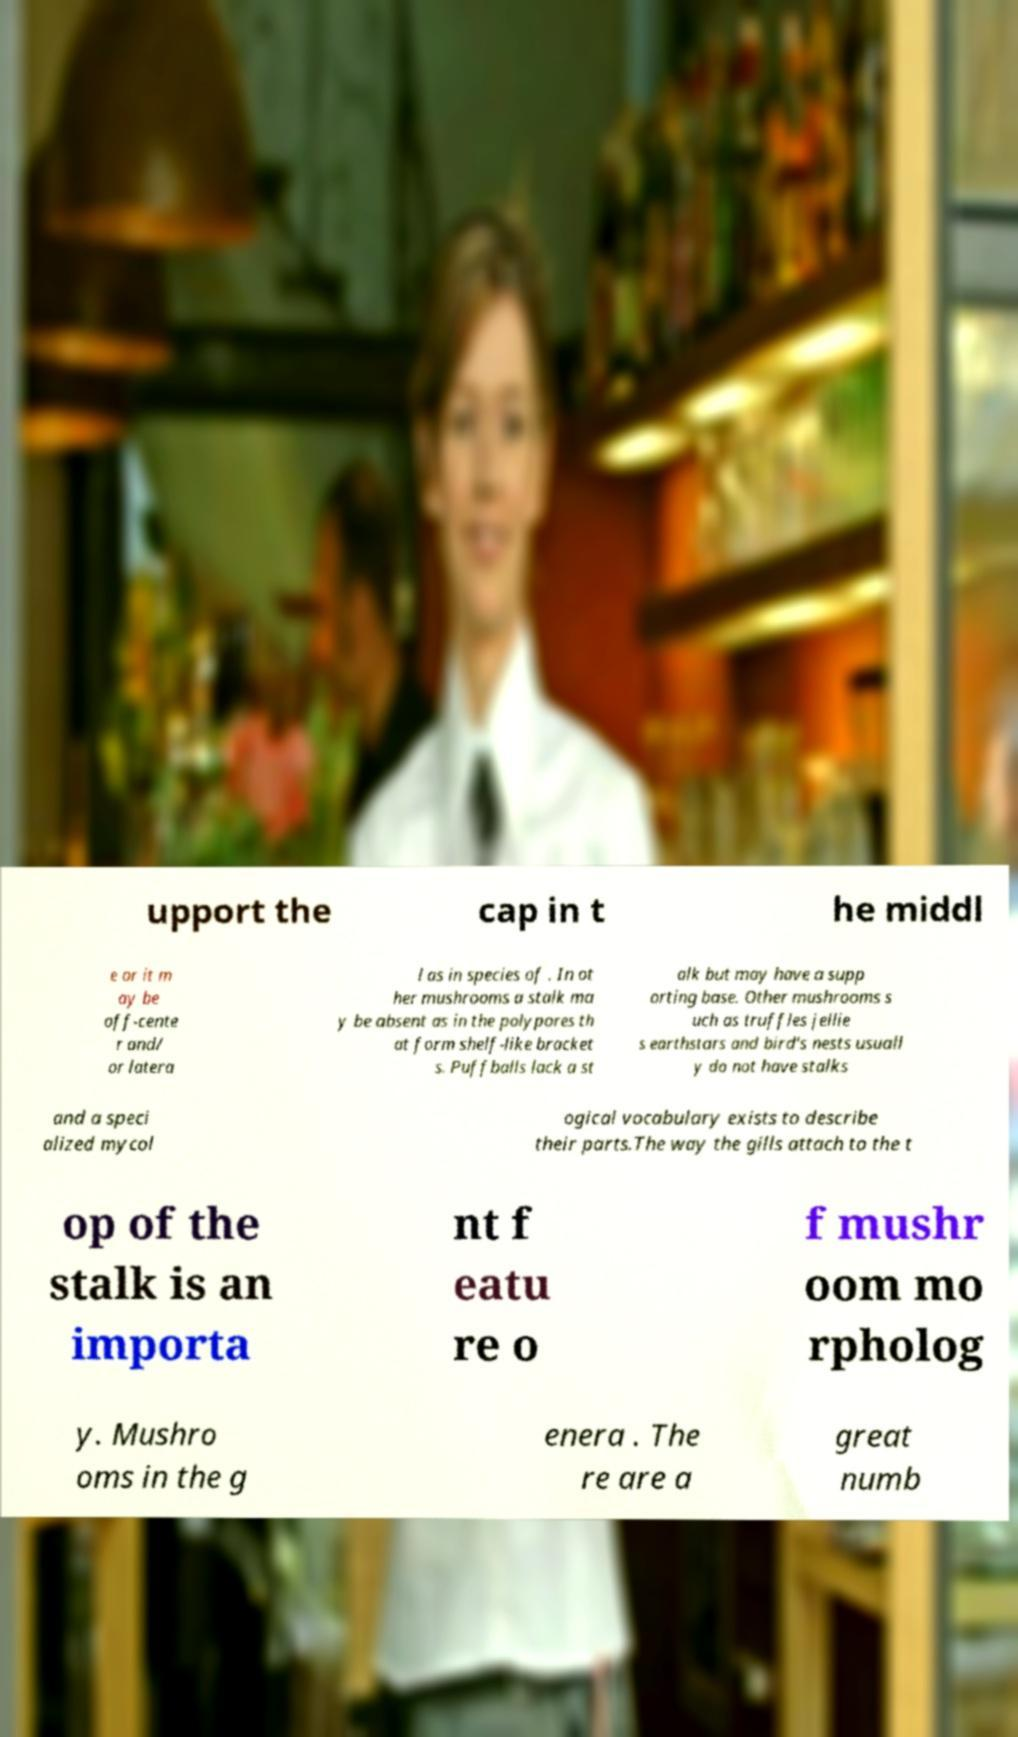Could you assist in decoding the text presented in this image and type it out clearly? upport the cap in t he middl e or it m ay be off-cente r and/ or latera l as in species of . In ot her mushrooms a stalk ma y be absent as in the polypores th at form shelf-like bracket s. Puffballs lack a st alk but may have a supp orting base. Other mushrooms s uch as truffles jellie s earthstars and bird's nests usuall y do not have stalks and a speci alized mycol ogical vocabulary exists to describe their parts.The way the gills attach to the t op of the stalk is an importa nt f eatu re o f mushr oom mo rpholog y. Mushro oms in the g enera . The re are a great numb 